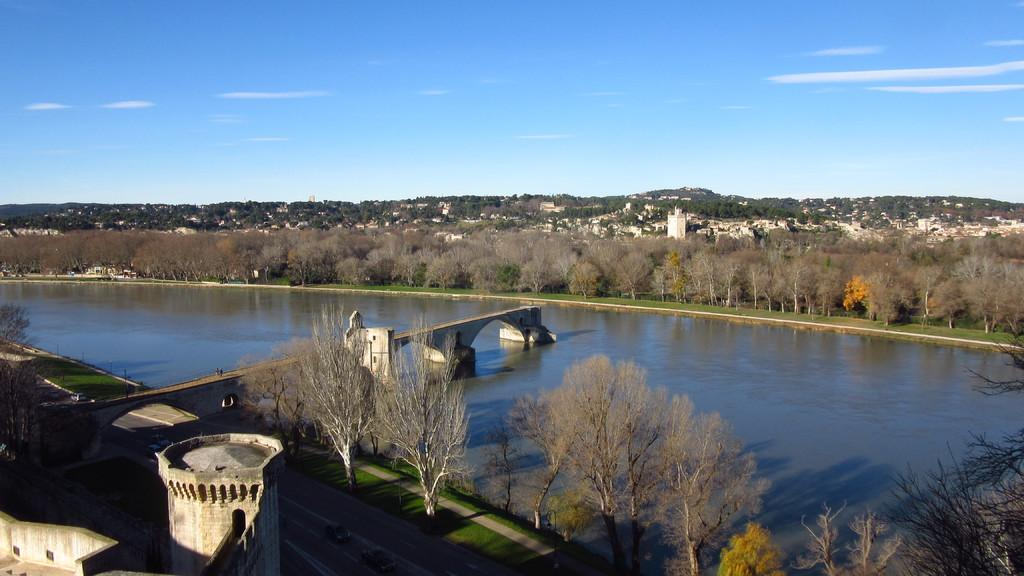What is the primary element visible in the image? There is water in the image. What structure can be seen crossing the water? There is a bridge in the image. What type of pathway is present in the image? There is a road in the image. What mode of transportation can be seen in the image? There are vehicles in the image. What type of natural vegetation is present in the image? There are trees in the image. What type of historical structures are present in the image? Ancient architecture is present in the image. What type of man-made structures are present in the image? There are buildings in the image. What is visible in the background of the image? The sky is visible in the background of the image. What atmospheric feature can be seen in the sky? There are clouds in the sky. How many nuts are hanging from the trees in the image? There are no nuts mentioned or visible in the image. 